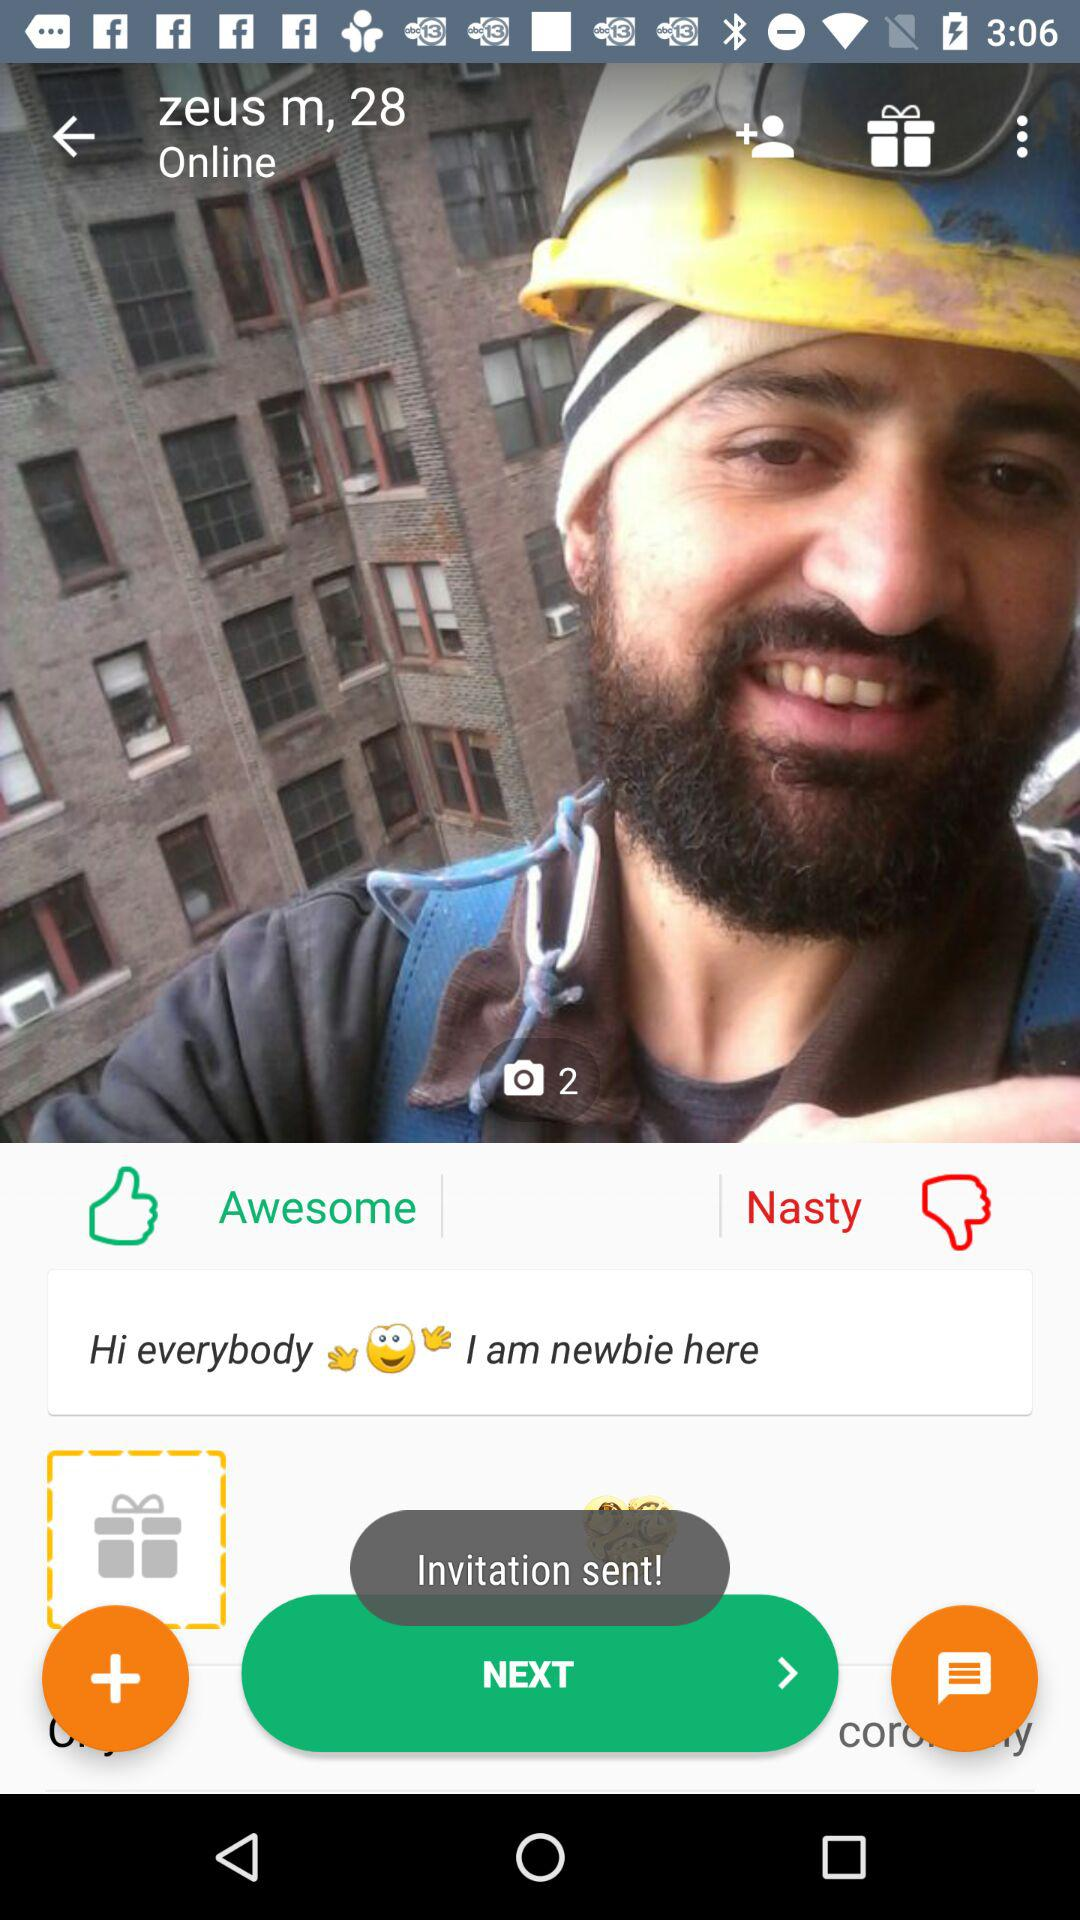What is the count of images shown? The count of shown images is 2. 